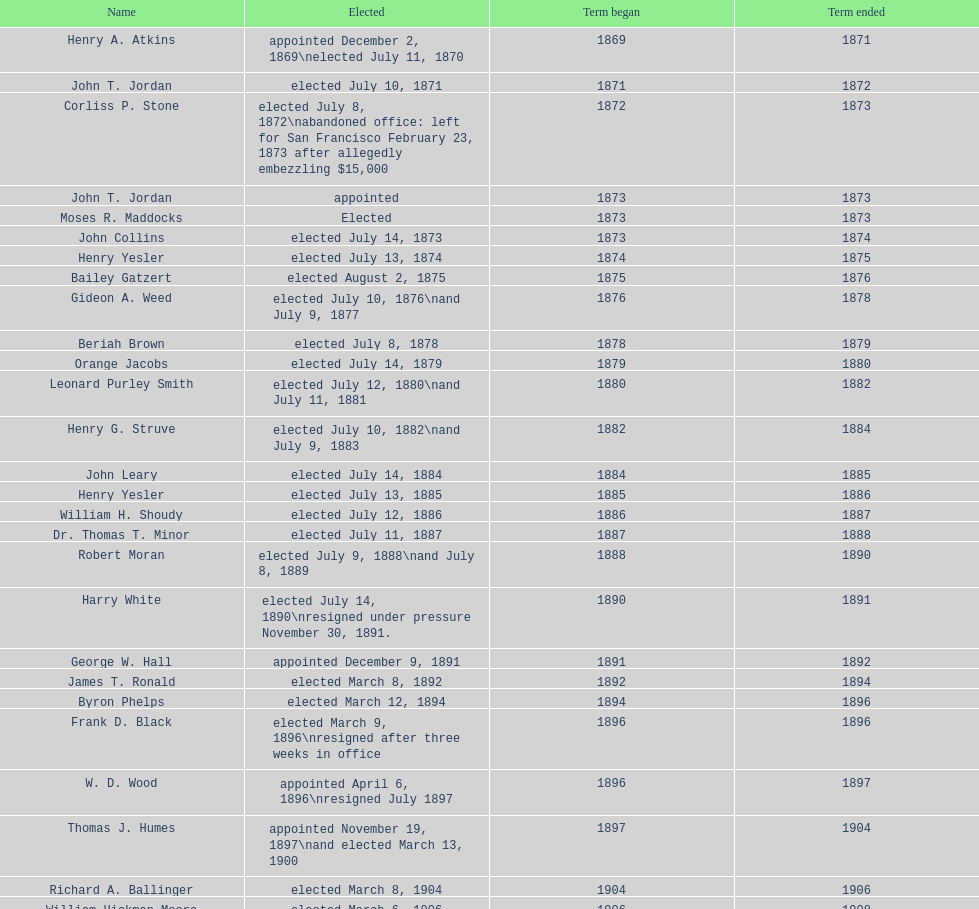Who was the mayor before jordan? Henry A. Atkins. 